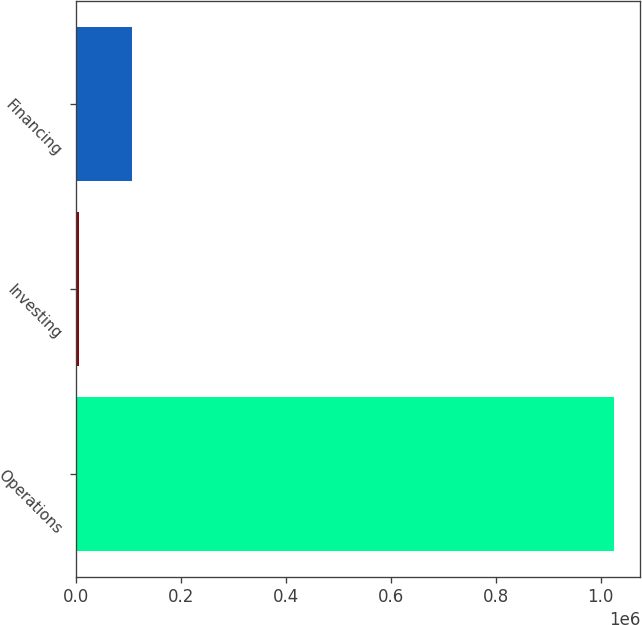<chart> <loc_0><loc_0><loc_500><loc_500><bar_chart><fcel>Operations<fcel>Investing<fcel>Financing<nl><fcel>1.02444e+06<fcel>5560<fcel>107448<nl></chart> 